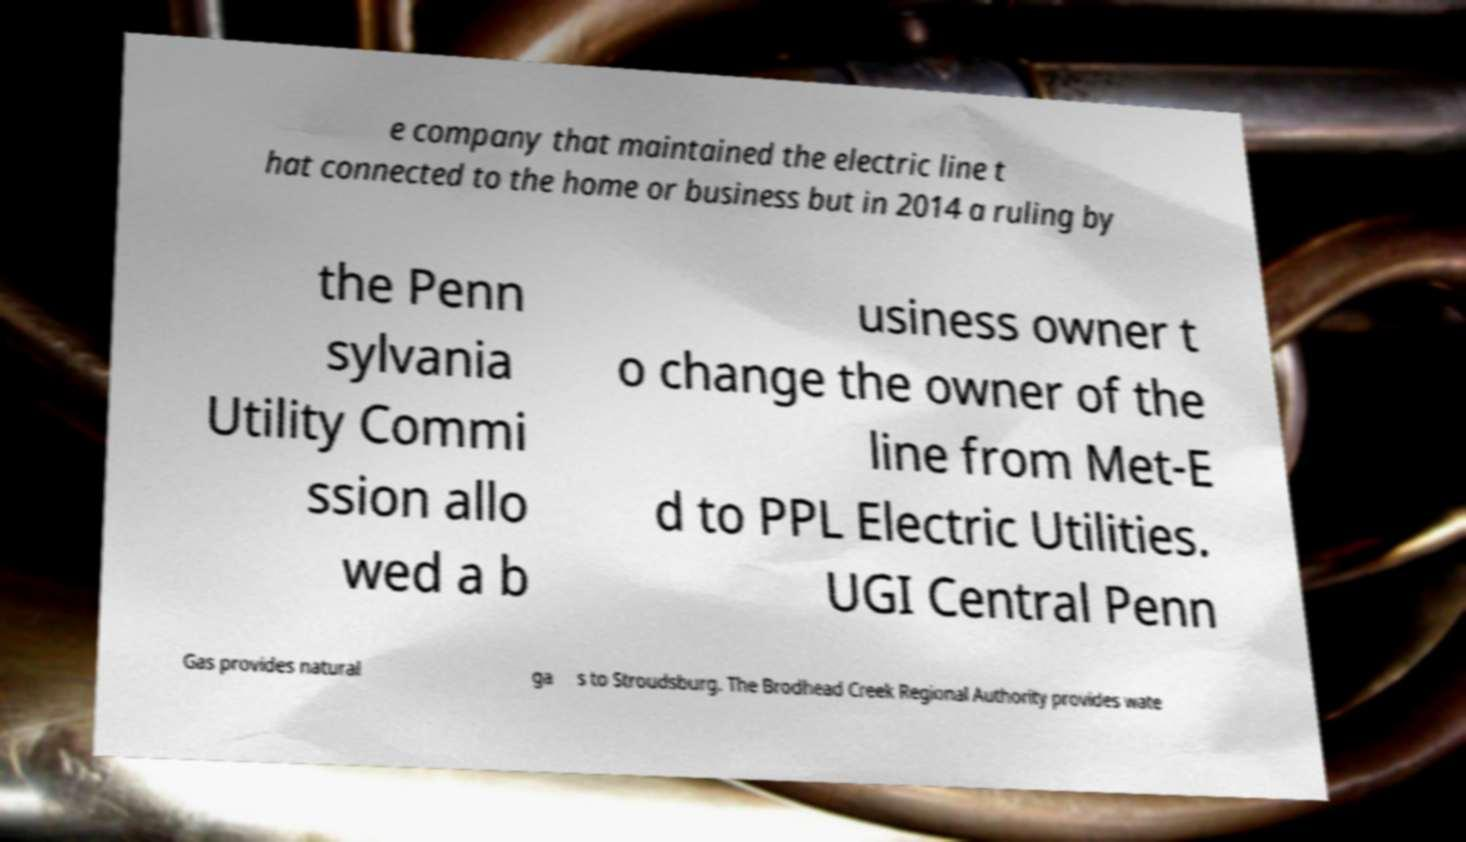Could you assist in decoding the text presented in this image and type it out clearly? e company that maintained the electric line t hat connected to the home or business but in 2014 a ruling by the Penn sylvania Utility Commi ssion allo wed a b usiness owner t o change the owner of the line from Met-E d to PPL Electric Utilities. UGI Central Penn Gas provides natural ga s to Stroudsburg. The Brodhead Creek Regional Authority provides wate 